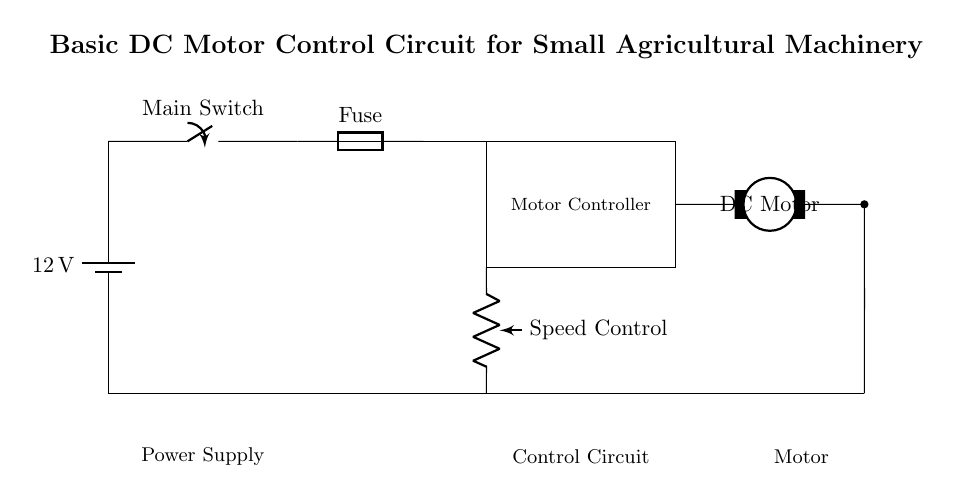What is the voltage of the power supply? The voltage is indicated next to the battery symbol, which shows it is 12 volts.
Answer: 12 volts What component controls the speed of the motor? The component labeled "Speed Control" is a potentiometer, which is typically used for adjusting the speed of the motor in the circuit.
Answer: Potentiometer How many main components are in the control circuit? The control circuit consists of the motor controller and the speed control potentiometer, totaling two main components in addition to the switches and fuses.
Answer: Two What happens to the power if the main switch is open? An open main switch represents a break in the circuit, preventing the current from flowing and thus disabling all the components downstream, including the motor.
Answer: Current stops What is the purpose of the fuse? The fuse is a protective device that interrupts the circuit in the event of excessive current, preventing damage to the components, specifically the motor and controller.
Answer: Protection Which component provides direct electrical connection to ground? The circuit includes a ground connection that runs from the power supply end to the motor, representing a return path for electric current.
Answer: Ground connection 